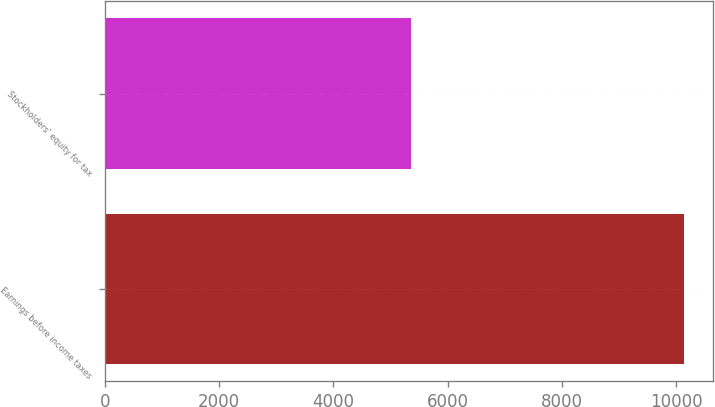Convert chart. <chart><loc_0><loc_0><loc_500><loc_500><bar_chart><fcel>Earnings before income taxes<fcel>Stockholders' equity for tax<nl><fcel>10137<fcel>5361<nl></chart> 